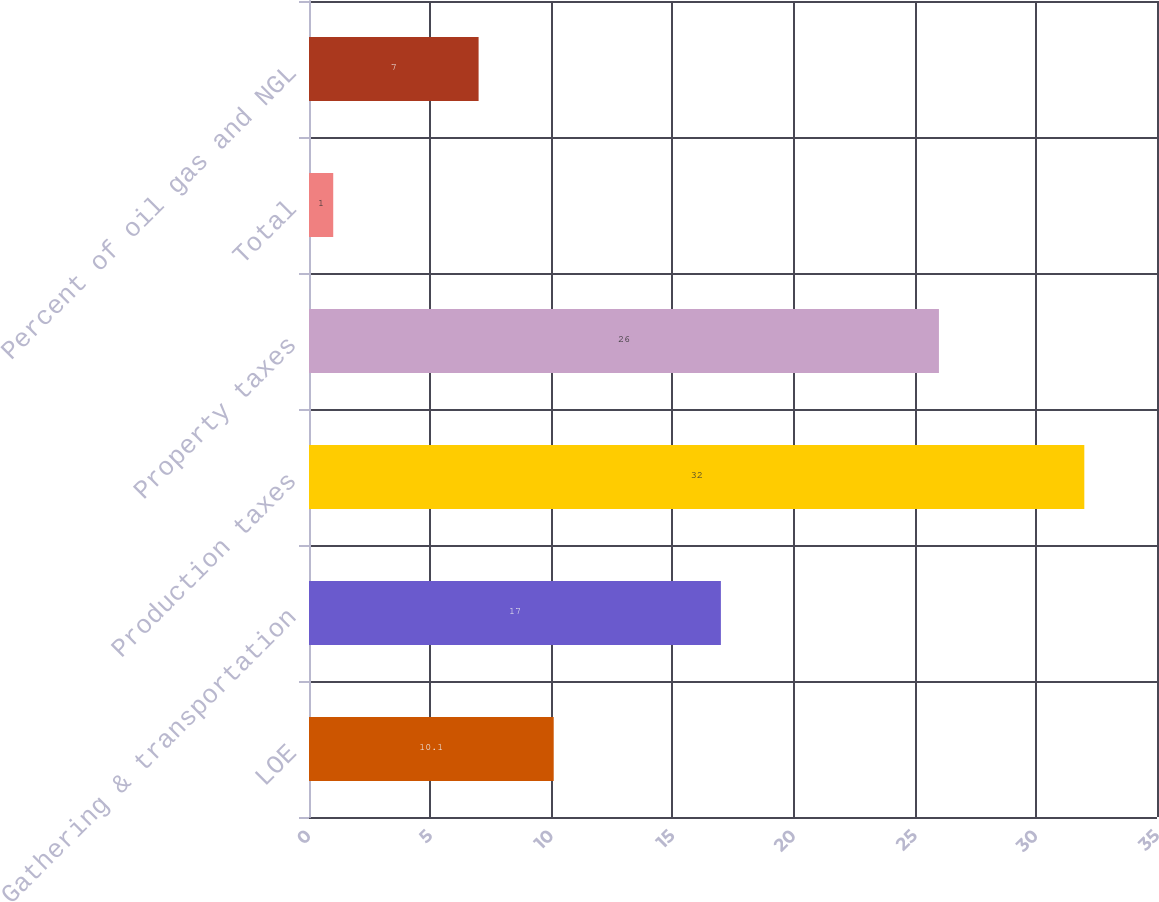Convert chart. <chart><loc_0><loc_0><loc_500><loc_500><bar_chart><fcel>LOE<fcel>Gathering & transportation<fcel>Production taxes<fcel>Property taxes<fcel>Total<fcel>Percent of oil gas and NGL<nl><fcel>10.1<fcel>17<fcel>32<fcel>26<fcel>1<fcel>7<nl></chart> 